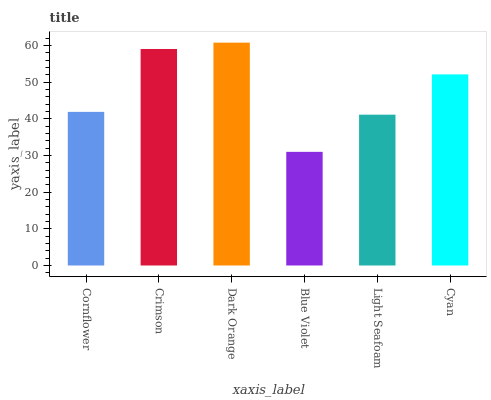Is Blue Violet the minimum?
Answer yes or no. Yes. Is Dark Orange the maximum?
Answer yes or no. Yes. Is Crimson the minimum?
Answer yes or no. No. Is Crimson the maximum?
Answer yes or no. No. Is Crimson greater than Cornflower?
Answer yes or no. Yes. Is Cornflower less than Crimson?
Answer yes or no. Yes. Is Cornflower greater than Crimson?
Answer yes or no. No. Is Crimson less than Cornflower?
Answer yes or no. No. Is Cyan the high median?
Answer yes or no. Yes. Is Cornflower the low median?
Answer yes or no. Yes. Is Dark Orange the high median?
Answer yes or no. No. Is Crimson the low median?
Answer yes or no. No. 